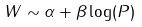Convert formula to latex. <formula><loc_0><loc_0><loc_500><loc_500>W \sim \alpha + \beta \log ( P )</formula> 